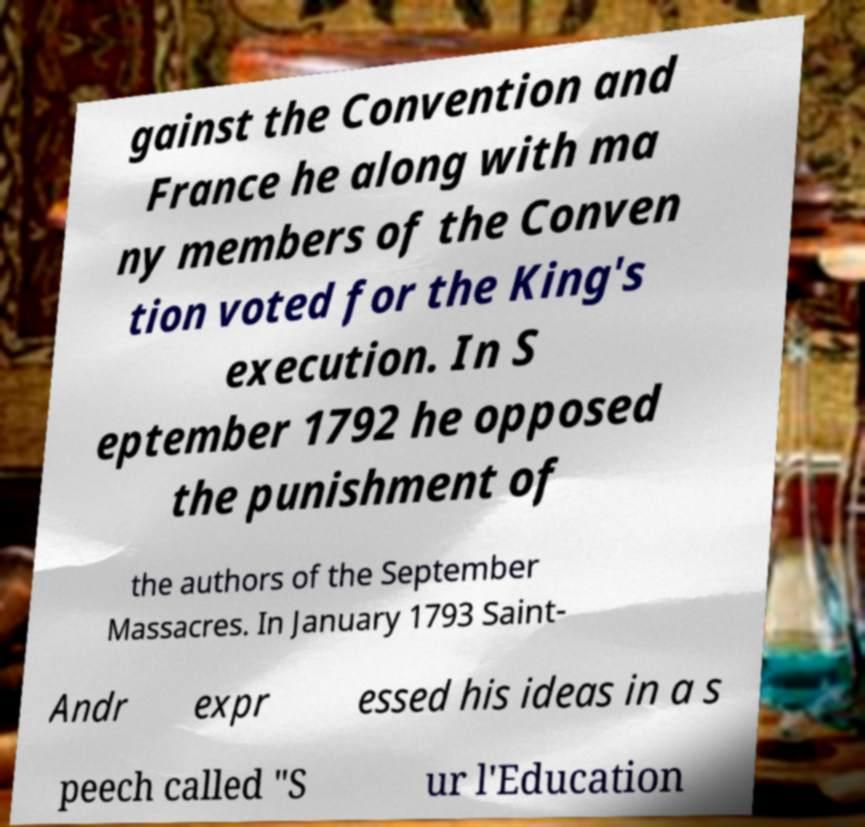I need the written content from this picture converted into text. Can you do that? gainst the Convention and France he along with ma ny members of the Conven tion voted for the King's execution. In S eptember 1792 he opposed the punishment of the authors of the September Massacres. In January 1793 Saint- Andr expr essed his ideas in a s peech called "S ur l'Education 